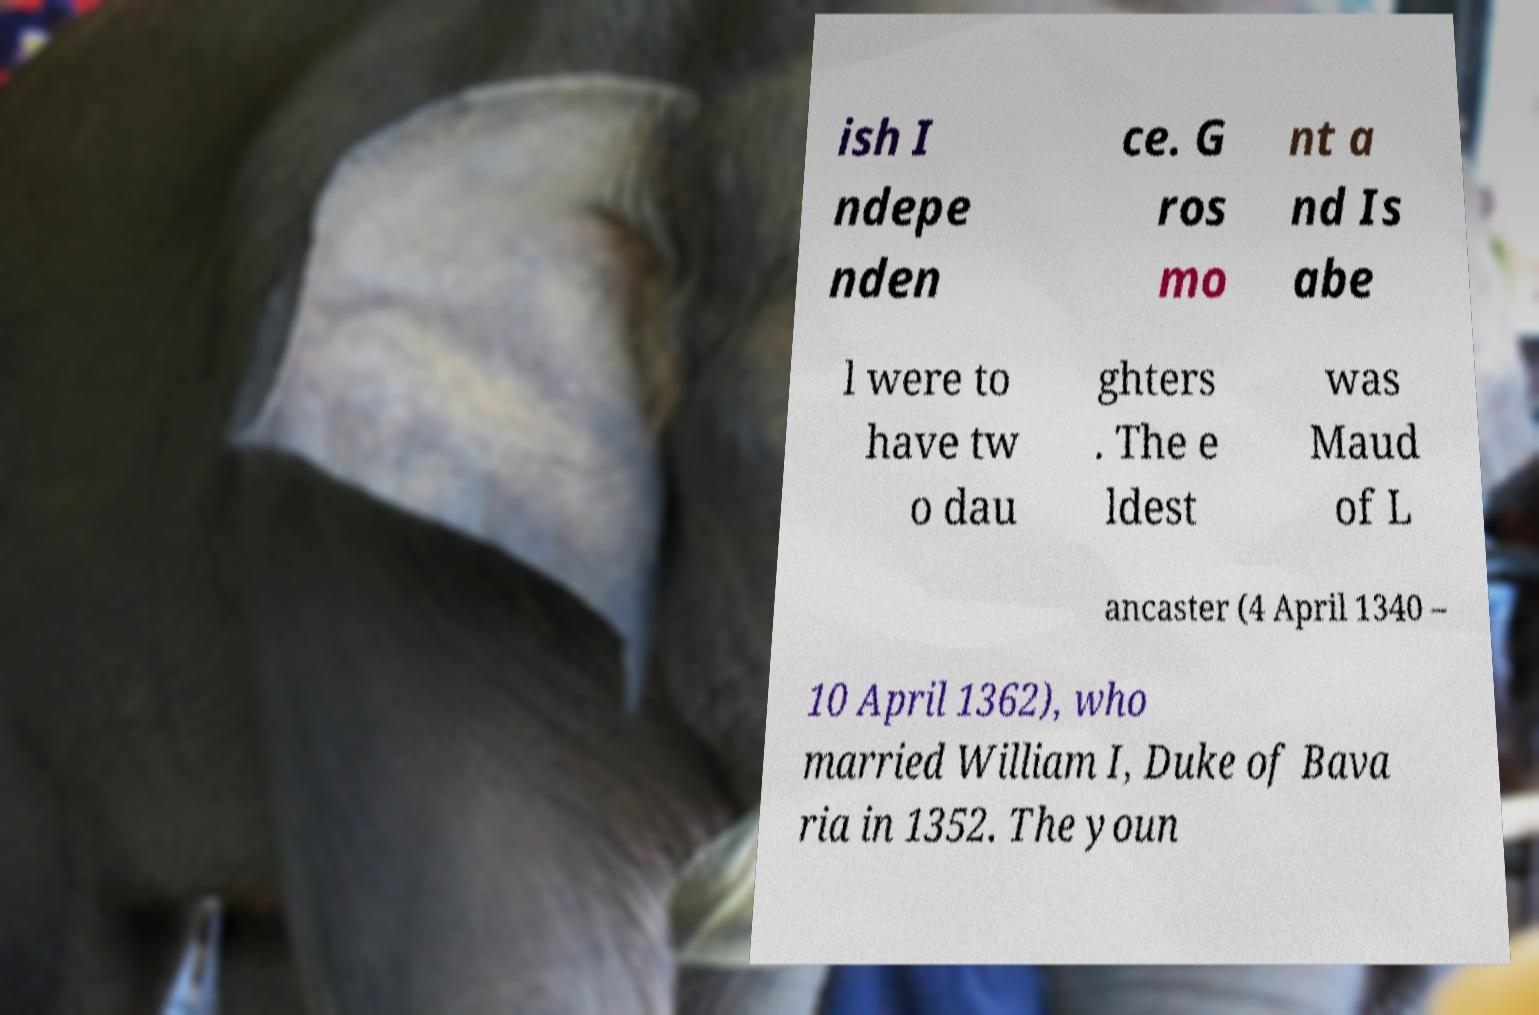Can you read and provide the text displayed in the image?This photo seems to have some interesting text. Can you extract and type it out for me? ish I ndepe nden ce. G ros mo nt a nd Is abe l were to have tw o dau ghters . The e ldest was Maud of L ancaster (4 April 1340 – 10 April 1362), who married William I, Duke of Bava ria in 1352. The youn 